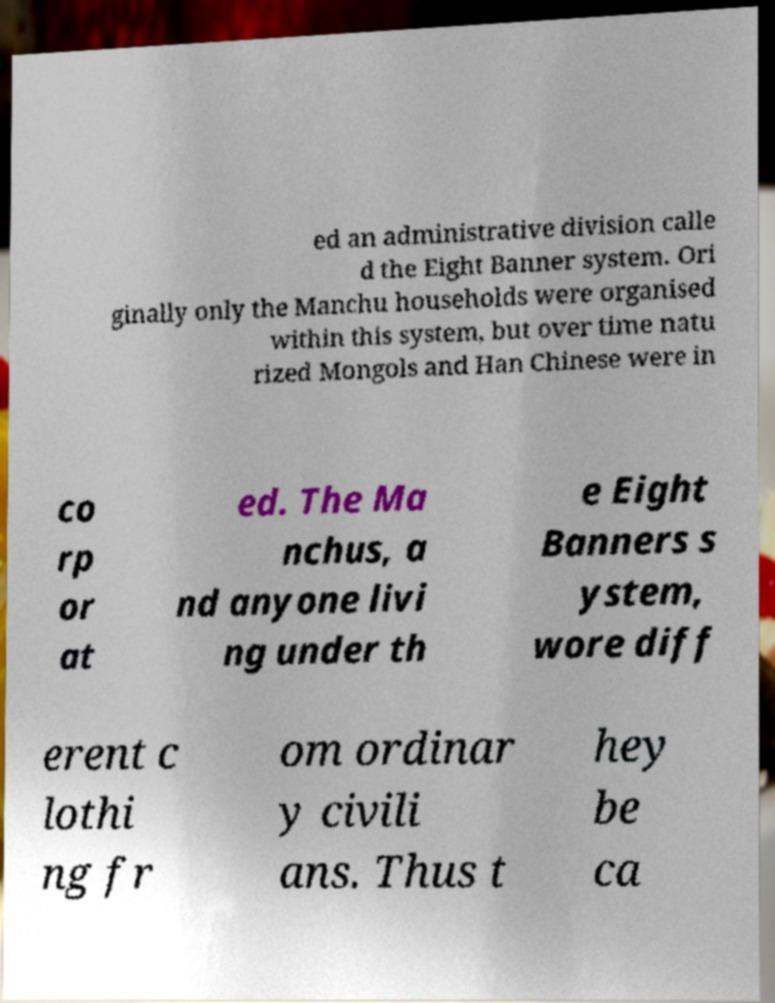For documentation purposes, I need the text within this image transcribed. Could you provide that? ed an administrative division calle d the Eight Banner system. Ori ginally only the Manchu households were organised within this system, but over time natu rized Mongols and Han Chinese were in co rp or at ed. The Ma nchus, a nd anyone livi ng under th e Eight Banners s ystem, wore diff erent c lothi ng fr om ordinar y civili ans. Thus t hey be ca 